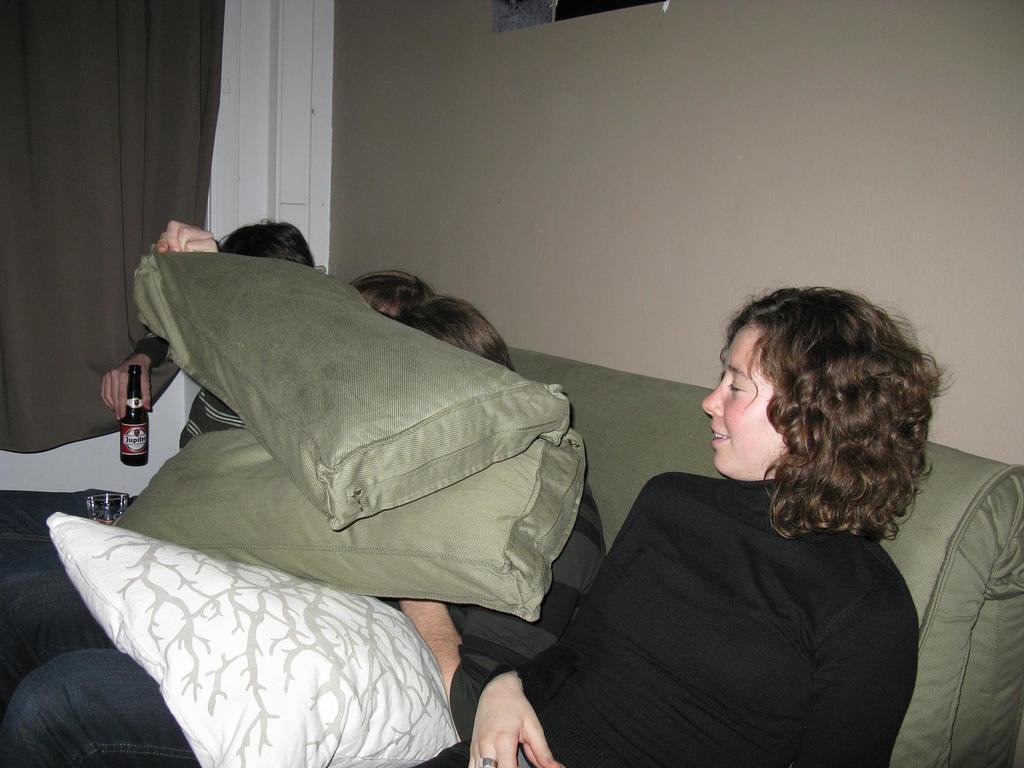Can you describe this image briefly? As we can see in the image, there is a wall, curtain, few people sleeping on bed and pillows. 